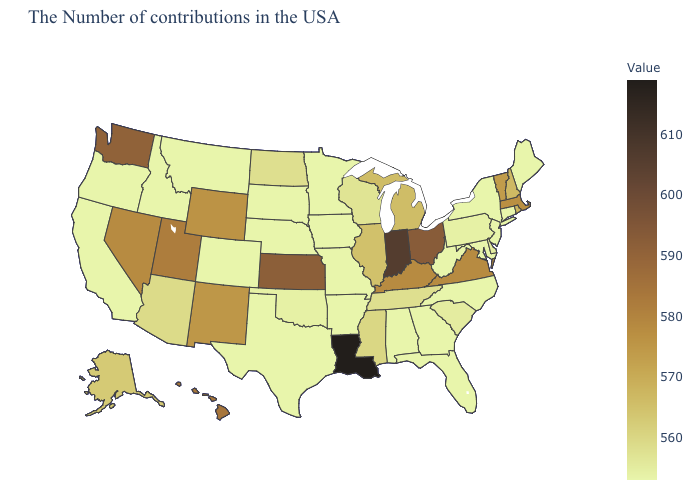Among the states that border Delaware , does Maryland have the lowest value?
Concise answer only. Yes. Which states have the lowest value in the USA?
Give a very brief answer. Maine, Connecticut, New York, New Jersey, Maryland, North Carolina, West Virginia, Florida, Georgia, Alabama, Missouri, Arkansas, Minnesota, Iowa, Nebraska, Texas, South Dakota, Colorado, Montana, Idaho, California, Oregon. Which states hav the highest value in the Northeast?
Quick response, please. Massachusetts. Which states have the lowest value in the USA?
Short answer required. Maine, Connecticut, New York, New Jersey, Maryland, North Carolina, West Virginia, Florida, Georgia, Alabama, Missouri, Arkansas, Minnesota, Iowa, Nebraska, Texas, South Dakota, Colorado, Montana, Idaho, California, Oregon. 